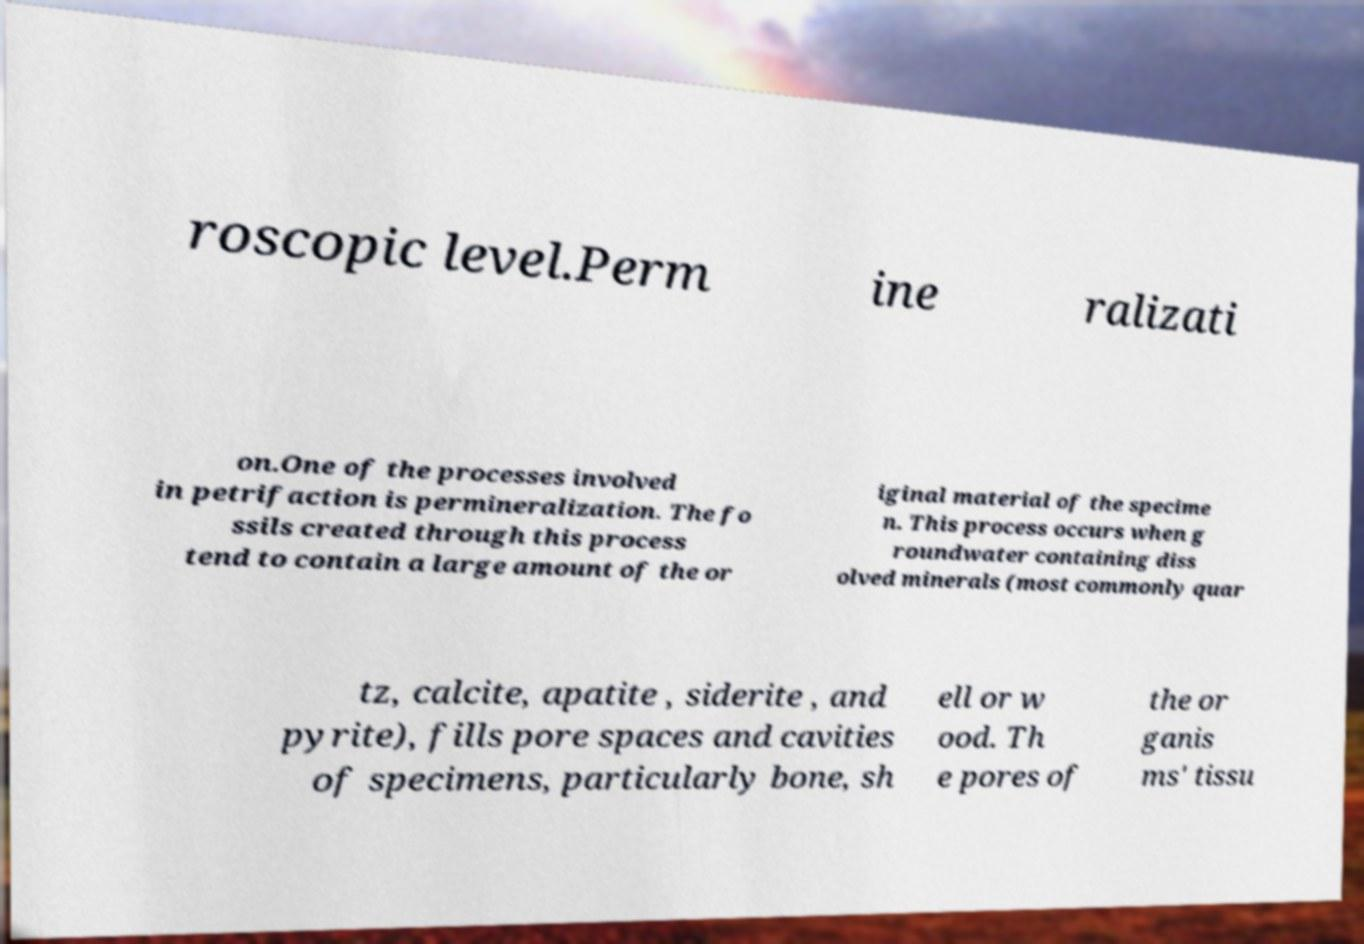What messages or text are displayed in this image? I need them in a readable, typed format. roscopic level.Perm ine ralizati on.One of the processes involved in petrifaction is permineralization. The fo ssils created through this process tend to contain a large amount of the or iginal material of the specime n. This process occurs when g roundwater containing diss olved minerals (most commonly quar tz, calcite, apatite , siderite , and pyrite), fills pore spaces and cavities of specimens, particularly bone, sh ell or w ood. Th e pores of the or ganis ms' tissu 